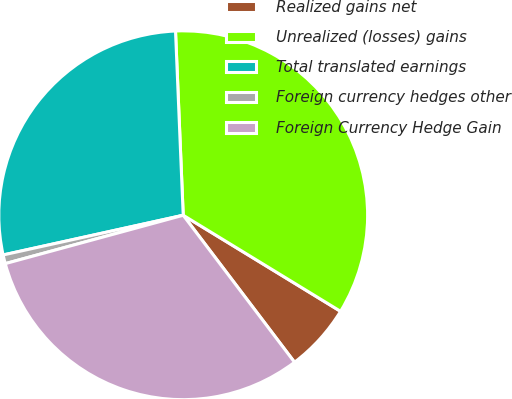Convert chart to OTSL. <chart><loc_0><loc_0><loc_500><loc_500><pie_chart><fcel>Realized gains net<fcel>Unrealized (losses) gains<fcel>Total translated earnings<fcel>Foreign currency hedges other<fcel>Foreign Currency Hedge Gain<nl><fcel>5.96%<fcel>34.39%<fcel>27.79%<fcel>0.77%<fcel>31.09%<nl></chart> 